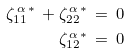Convert formula to latex. <formula><loc_0><loc_0><loc_500><loc_500>\zeta ^ { \, \alpha \, * } _ { 1 1 } \, + \zeta ^ { \, \alpha \, * } _ { 2 2 } \, = \, 0 \\ \zeta ^ { \, \alpha \, * } _ { 1 2 } \, = \, 0</formula> 